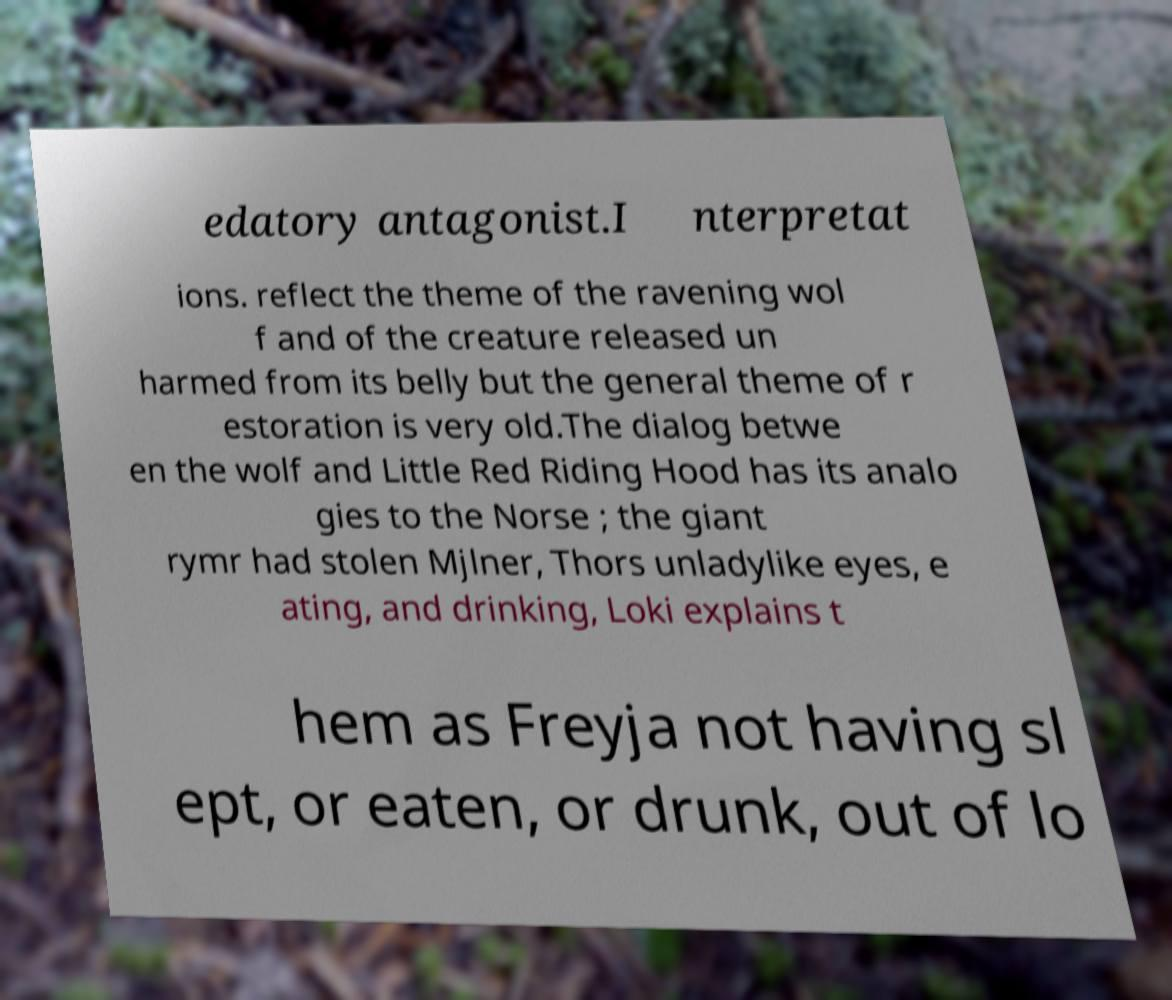What messages or text are displayed in this image? I need them in a readable, typed format. edatory antagonist.I nterpretat ions. reflect the theme of the ravening wol f and of the creature released un harmed from its belly but the general theme of r estoration is very old.The dialog betwe en the wolf and Little Red Riding Hood has its analo gies to the Norse ; the giant rymr had stolen Mjlner, Thors unladylike eyes, e ating, and drinking, Loki explains t hem as Freyja not having sl ept, or eaten, or drunk, out of lo 